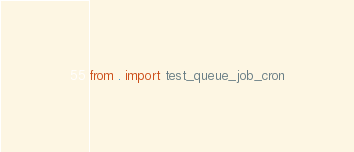Convert code to text. <code><loc_0><loc_0><loc_500><loc_500><_Python_>from . import test_queue_job_cron
</code> 